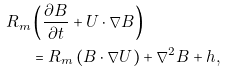Convert formula to latex. <formula><loc_0><loc_0><loc_500><loc_500>R _ { m } & \left ( \frac { \partial B } { \partial t } + U \cdot \nabla B \right ) \\ & = R _ { m } \left ( B \cdot \nabla U \right ) + \nabla ^ { 2 } B + h ,</formula> 